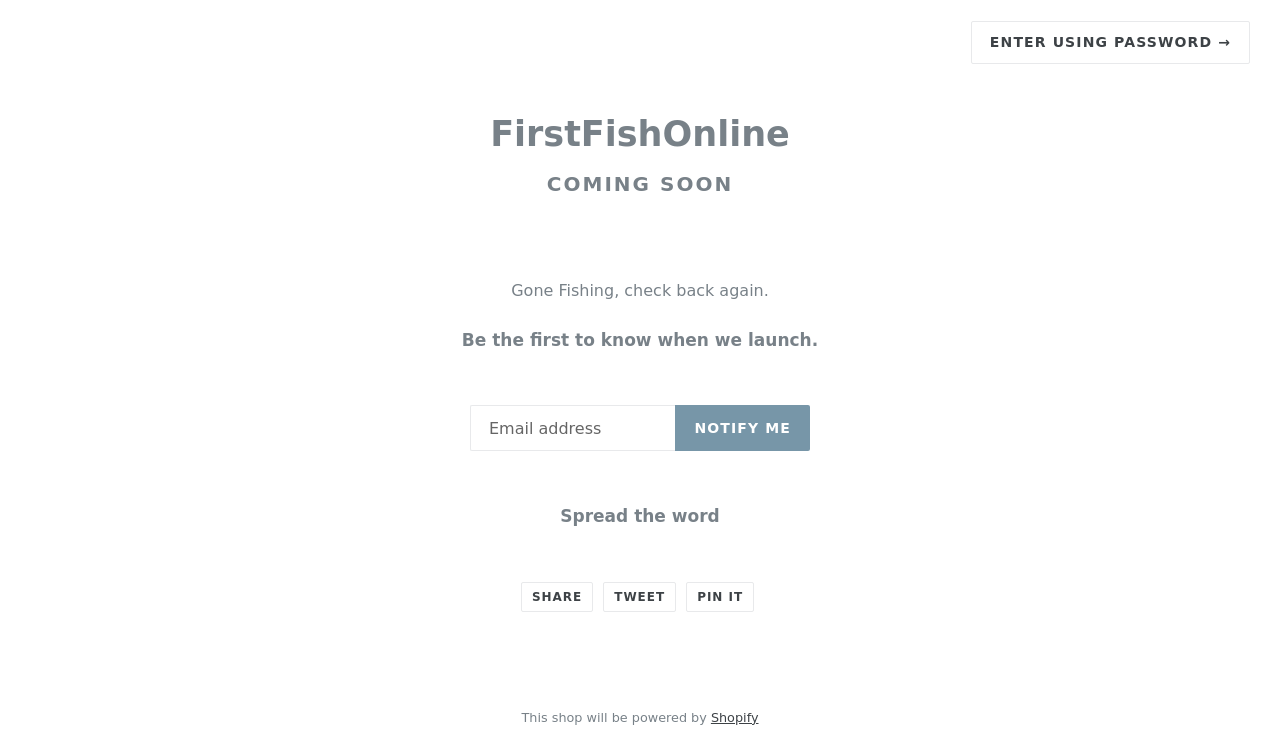Could you guide me through the process of developing this website with HTML? Building a website like the one in the image provided, which appears to be a 'Coming Soon' page for FirstFishOnline, starts with basic HTML for structure. Here's a simple example:

```html
<!DOCTYPE html>
<html>
<head>
    <title>FirstFishOnline - Coming Soon</title>
    <link href='styles.css' rel='stylesheet' type='text/css'>
</head>
<body>
    <div class='coming-soon'>
        <h1>FirstFishOnline</h1>
        <p>Gone Fishing, check back again.</p>
        <p>Be the first to know when we launch.</p>
        <form>
            <input type='email' placeholder='Email Address'>
            <button type='submit'>Notify Me</button>
        </form>
        <div>
            <a href='#'>Share</a>
            <a href='#'>Tweet</a>
            <a href='#'>Pin it</a>
        </div>
    </div>
</body>
</html>
```
This code provides a basic structure. You'll need CSS for styling and possibly JavaScript for functionality like handling the subscription form. 